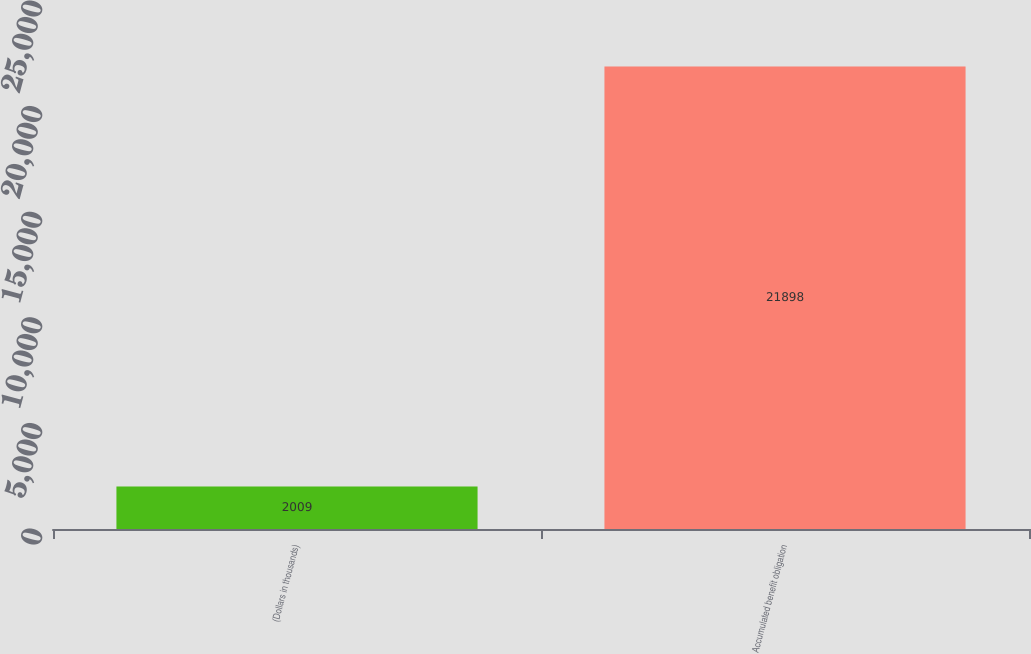<chart> <loc_0><loc_0><loc_500><loc_500><bar_chart><fcel>(Dollars in thousands)<fcel>Accumulated benefit obligation<nl><fcel>2009<fcel>21898<nl></chart> 